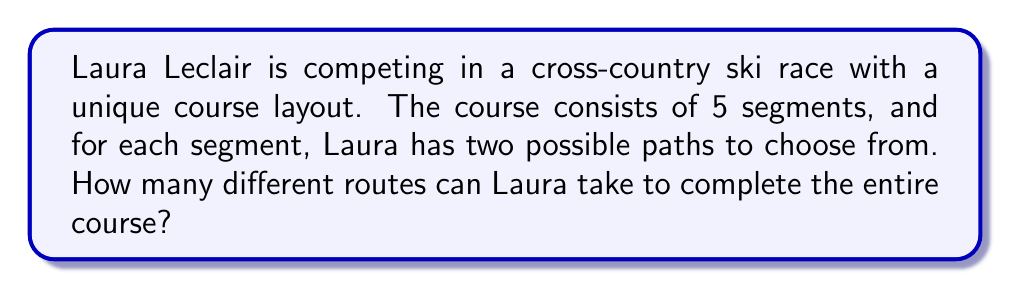Teach me how to tackle this problem. Let's approach this step-by-step:

1) For each segment of the course, Laura has 2 choices.

2) The total number of segments is 5.

3) This scenario follows the Multiplication Principle of Counting. When we have a sequence of independent choices, the total number of possible outcomes is the product of the number of choices for each decision.

4) In this case, we have:
   - 2 choices for the 1st segment
   - 2 choices for the 2nd segment
   - 2 choices for the 3rd segment
   - 2 choices for the 4th segment
   - 2 choices for the 5th segment

5) Therefore, the total number of possible routes is:

   $$2 \times 2 \times 2 \times 2 \times 2 = 2^5$$

6) We can calculate this:

   $$2^5 = 32$$

Thus, Laura Leclair has 32 different possible routes to complete the cross-country ski course.
Answer: $32$ 